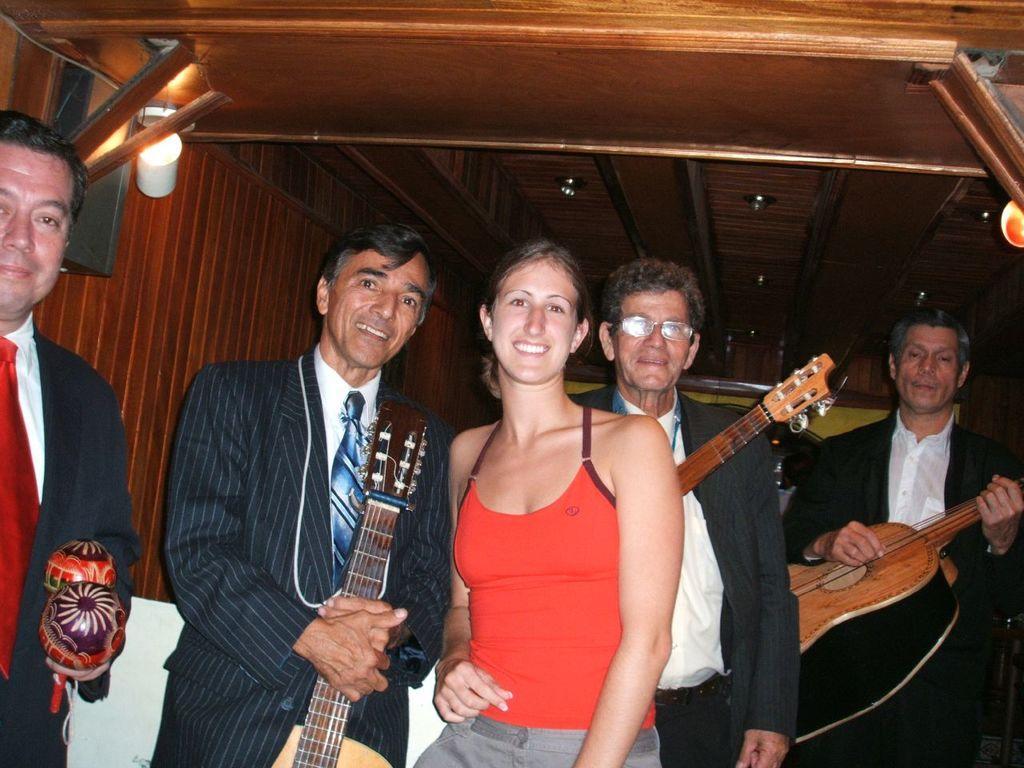Describe this image in one or two sentences. In this picture we can see all the persons standing and giving a pose to a camera and smiling. We can see men holding guitars in their hands. 